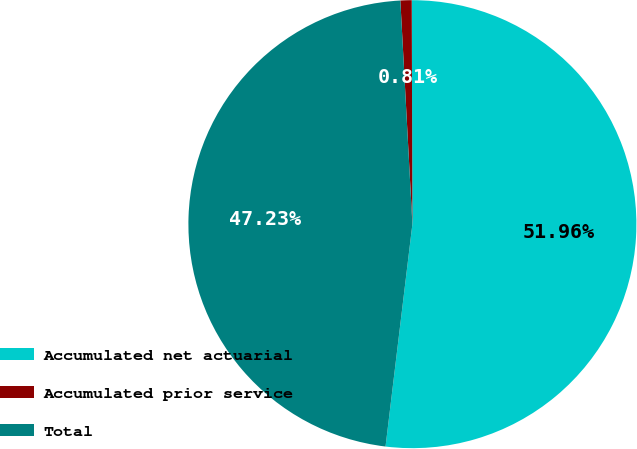Convert chart. <chart><loc_0><loc_0><loc_500><loc_500><pie_chart><fcel>Accumulated net actuarial<fcel>Accumulated prior service<fcel>Total<nl><fcel>51.96%<fcel>0.81%<fcel>47.23%<nl></chart> 